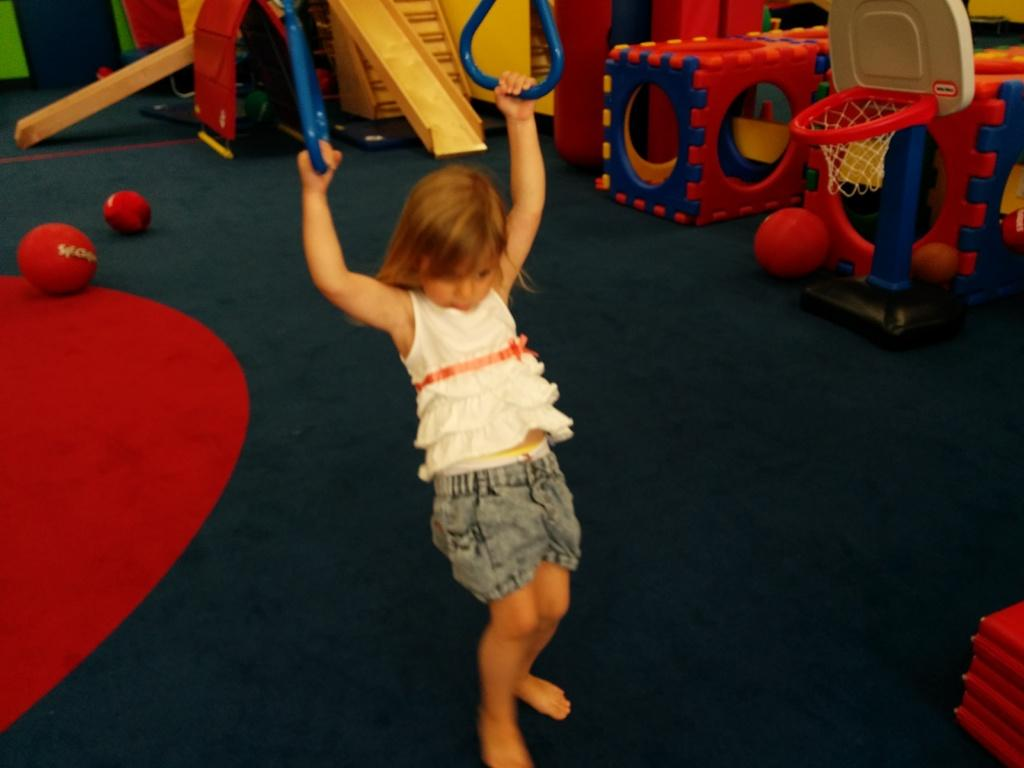What type of objects are on the ground in the image? There are playing objects on the ground in the image. Can you describe the specific objects on the ground? There are two balls on the ground. Who is present in the image? A girl is standing in the image. What is the girl holding in her hand? The girl is holding objects in her hand. How many hands are visible in the image? The image only shows a girl standing, and her hands are not visible. Is there a pipe being used by anyone in the image? There is no pipe present in the image. 